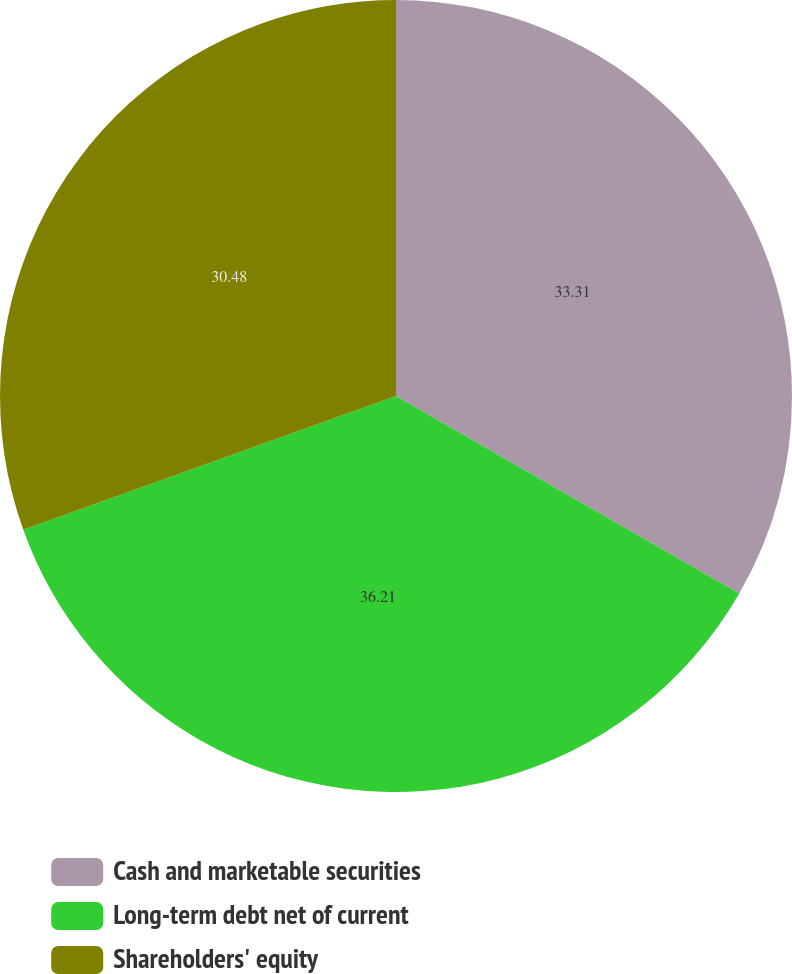Convert chart. <chart><loc_0><loc_0><loc_500><loc_500><pie_chart><fcel>Cash and marketable securities<fcel>Long-term debt net of current<fcel>Shareholders' equity<nl><fcel>33.31%<fcel>36.2%<fcel>30.48%<nl></chart> 